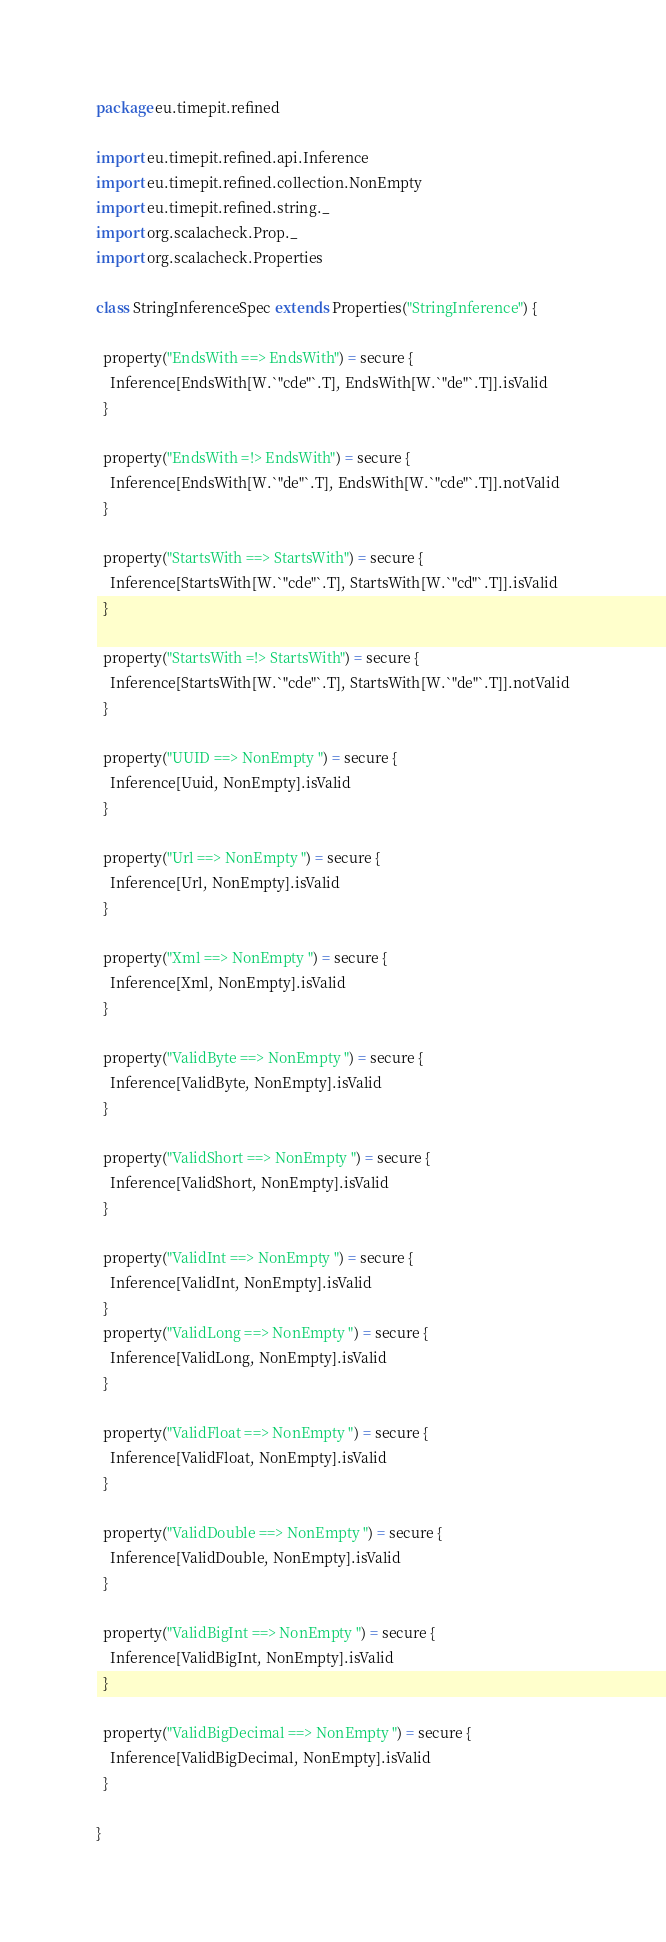Convert code to text. <code><loc_0><loc_0><loc_500><loc_500><_Scala_>package eu.timepit.refined

import eu.timepit.refined.api.Inference
import eu.timepit.refined.collection.NonEmpty
import eu.timepit.refined.string._
import org.scalacheck.Prop._
import org.scalacheck.Properties

class StringInferenceSpec extends Properties("StringInference") {

  property("EndsWith ==> EndsWith") = secure {
    Inference[EndsWith[W.`"cde"`.T], EndsWith[W.`"de"`.T]].isValid
  }

  property("EndsWith =!> EndsWith") = secure {
    Inference[EndsWith[W.`"de"`.T], EndsWith[W.`"cde"`.T]].notValid
  }

  property("StartsWith ==> StartsWith") = secure {
    Inference[StartsWith[W.`"cde"`.T], StartsWith[W.`"cd"`.T]].isValid
  }

  property("StartsWith =!> StartsWith") = secure {
    Inference[StartsWith[W.`"cde"`.T], StartsWith[W.`"de"`.T]].notValid
  }

  property("UUID ==> NonEmpty ") = secure {
    Inference[Uuid, NonEmpty].isValid
  }

  property("Url ==> NonEmpty ") = secure {
    Inference[Url, NonEmpty].isValid
  }

  property("Xml ==> NonEmpty ") = secure {
    Inference[Xml, NonEmpty].isValid
  }

  property("ValidByte ==> NonEmpty ") = secure {
    Inference[ValidByte, NonEmpty].isValid
  }

  property("ValidShort ==> NonEmpty ") = secure {
    Inference[ValidShort, NonEmpty].isValid
  }

  property("ValidInt ==> NonEmpty ") = secure {
    Inference[ValidInt, NonEmpty].isValid
  }
  property("ValidLong ==> NonEmpty ") = secure {
    Inference[ValidLong, NonEmpty].isValid
  }

  property("ValidFloat ==> NonEmpty ") = secure {
    Inference[ValidFloat, NonEmpty].isValid
  }

  property("ValidDouble ==> NonEmpty ") = secure {
    Inference[ValidDouble, NonEmpty].isValid
  }

  property("ValidBigInt ==> NonEmpty ") = secure {
    Inference[ValidBigInt, NonEmpty].isValid
  }

  property("ValidBigDecimal ==> NonEmpty ") = secure {
    Inference[ValidBigDecimal, NonEmpty].isValid
  }

}
</code> 